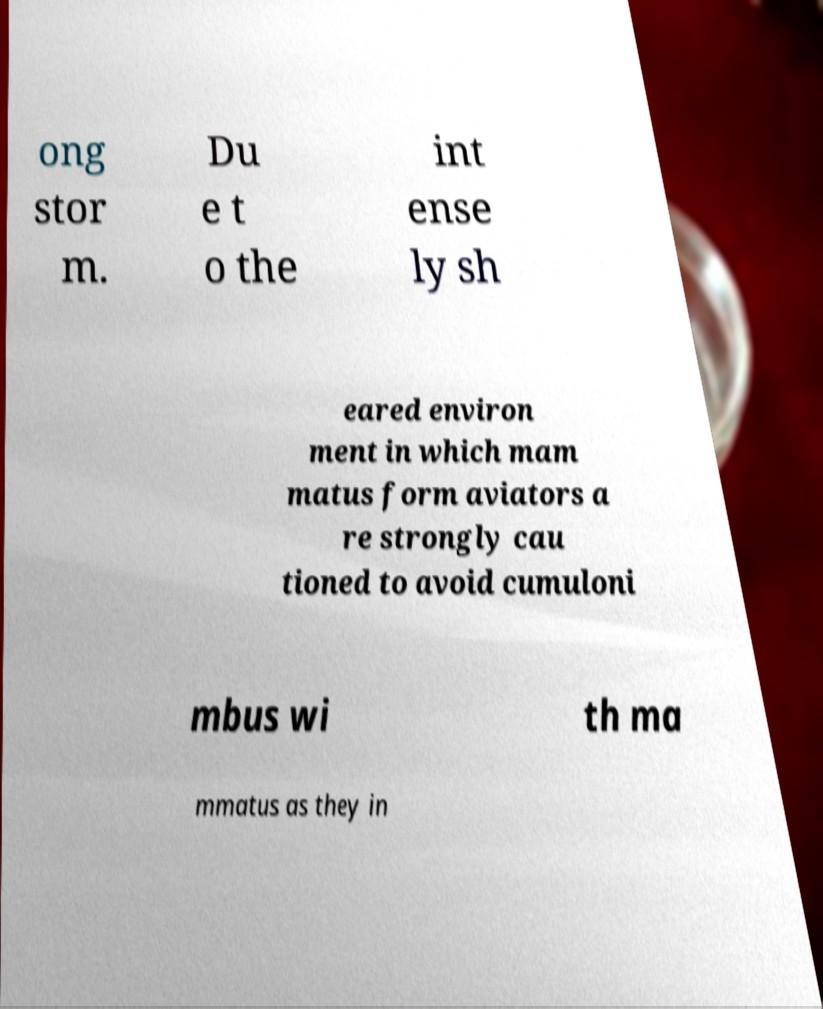I need the written content from this picture converted into text. Can you do that? ong stor m. Du e t o the int ense ly sh eared environ ment in which mam matus form aviators a re strongly cau tioned to avoid cumuloni mbus wi th ma mmatus as they in 